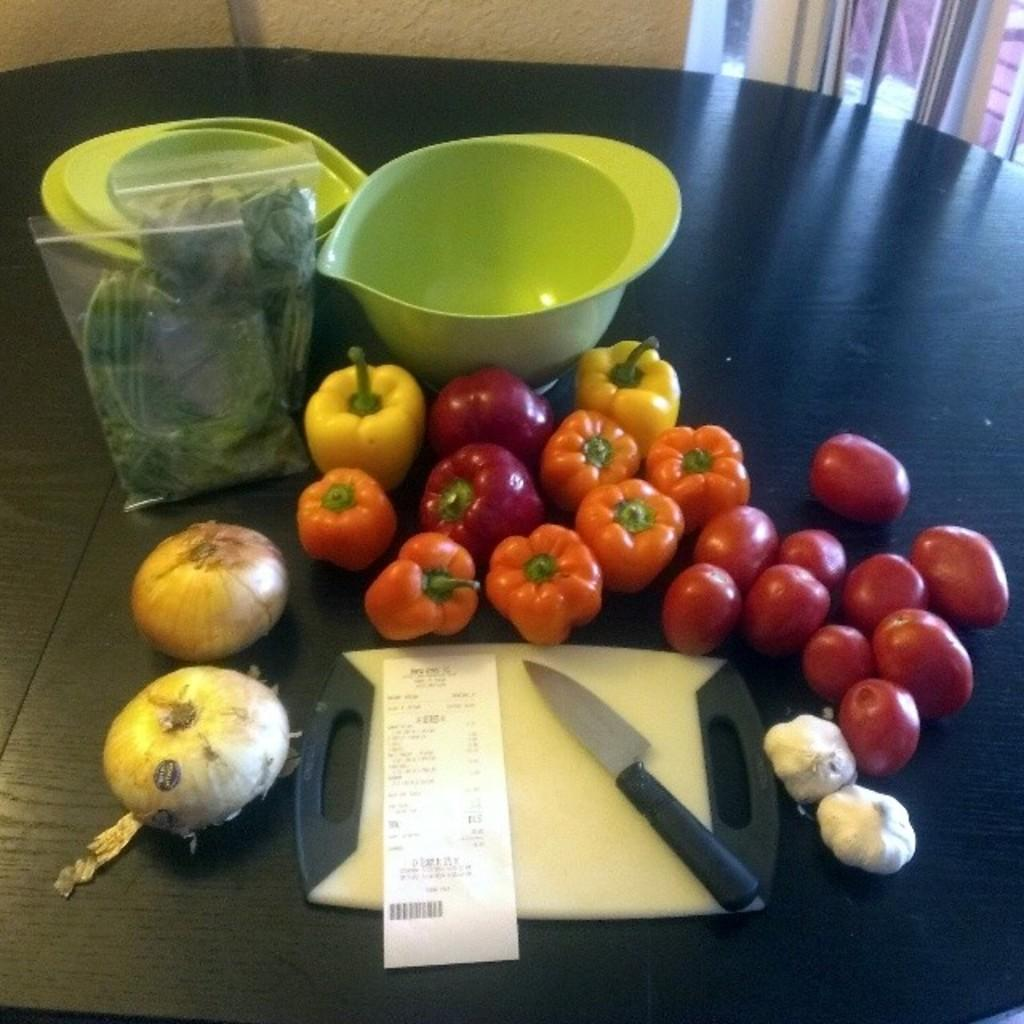What type of food items are visible in the image? There are vegetables in the image. What utensil can be seen in the image? There is a knife in the image. What type of container is present in the image? There are bowls in the image. What other objects are on the table in the image? There are other objects on the table, but their specific details are not mentioned in the provided facts. What type of paper is present in the image? There is a paper with text in the image, and it appears to be a bill. How many mines are visible in the image? There are no mines present in the image. What type of line is drawn on the table in the image? There is no line drawn on the table in the image. 